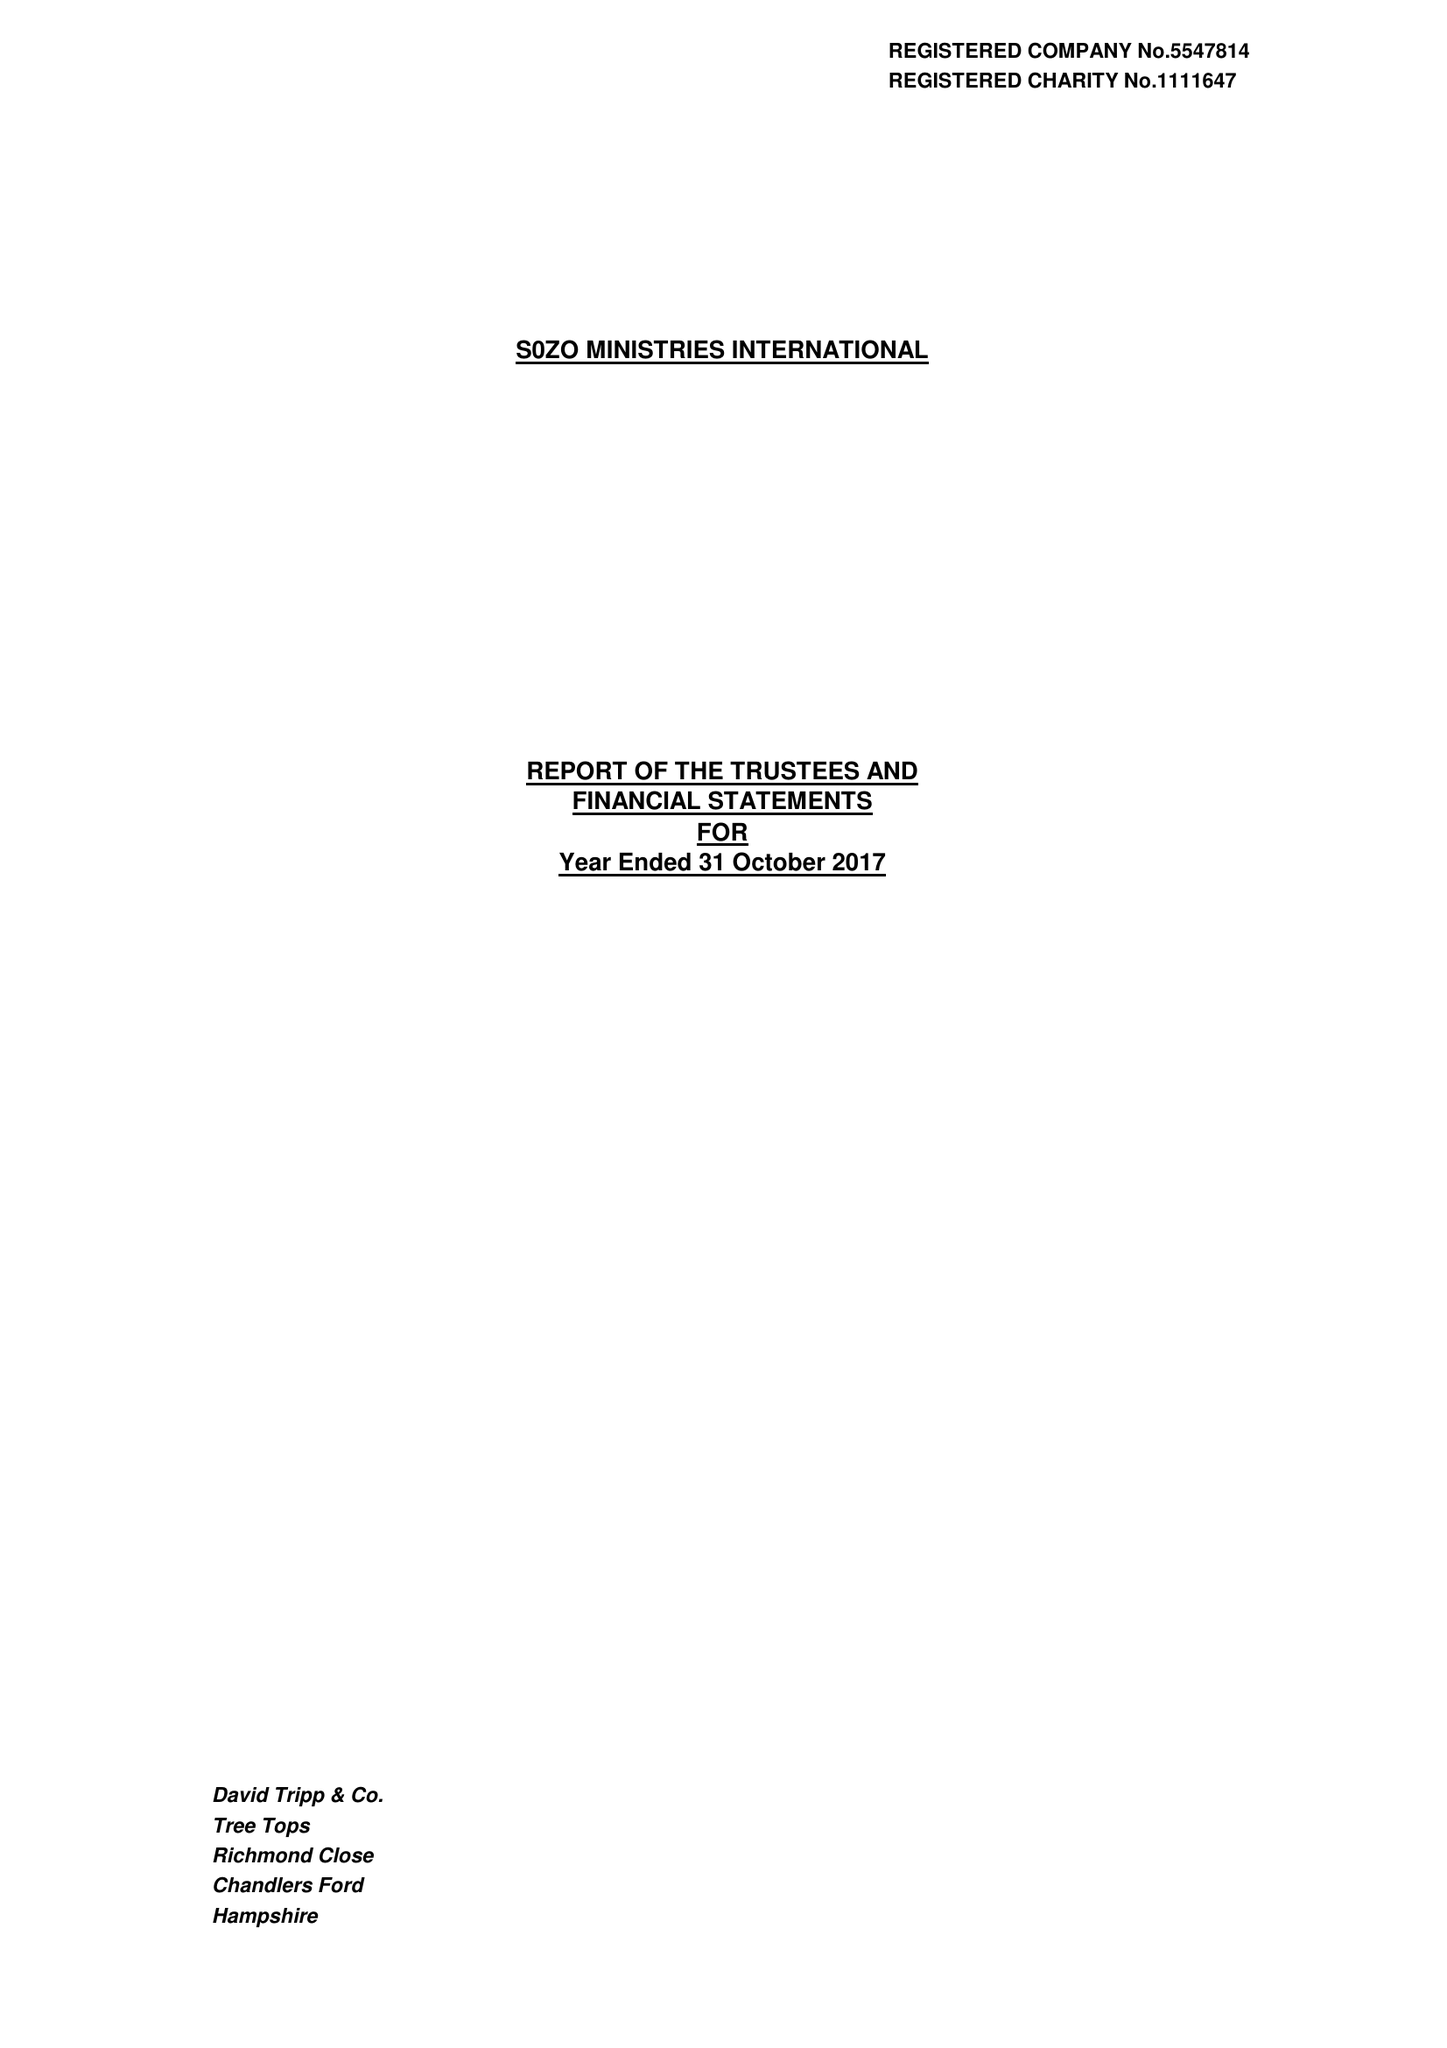What is the value for the spending_annually_in_british_pounds?
Answer the question using a single word or phrase. 256693.00 